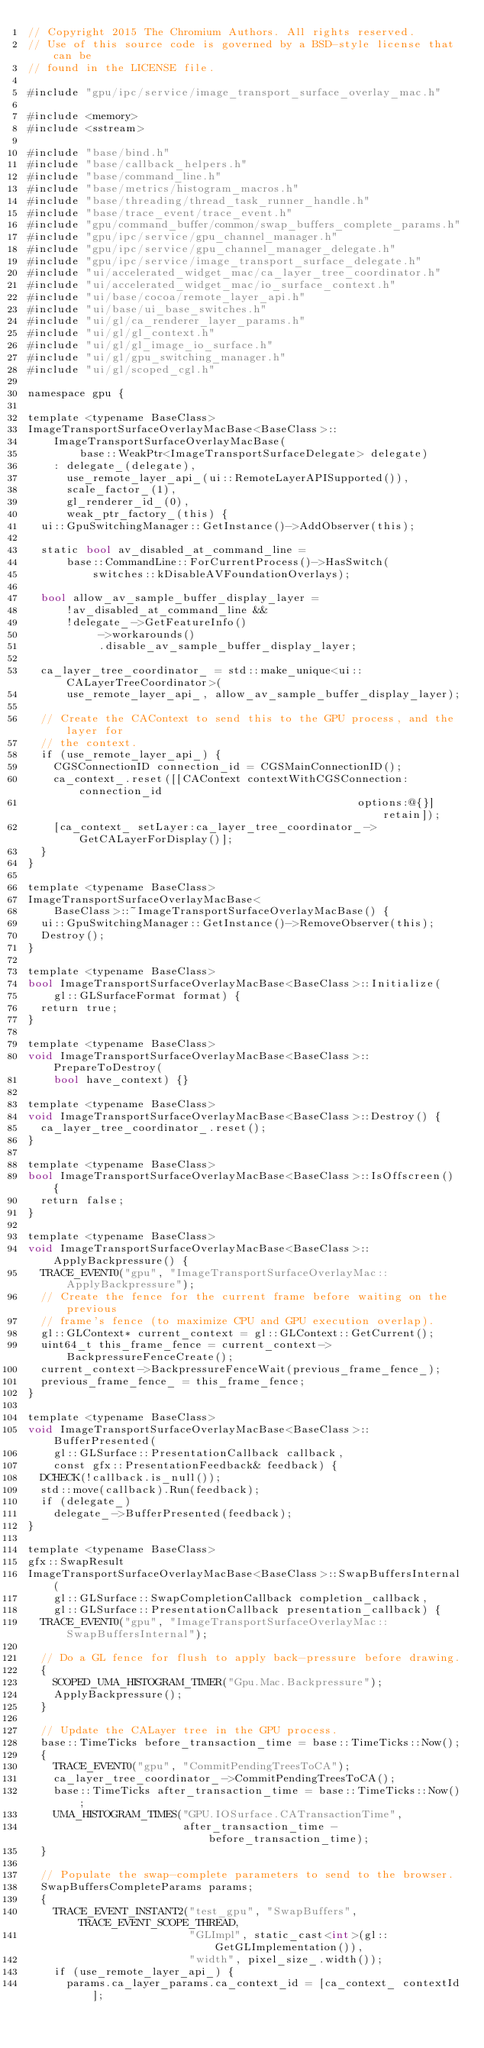<code> <loc_0><loc_0><loc_500><loc_500><_ObjectiveC_>// Copyright 2015 The Chromium Authors. All rights reserved.
// Use of this source code is governed by a BSD-style license that can be
// found in the LICENSE file.

#include "gpu/ipc/service/image_transport_surface_overlay_mac.h"

#include <memory>
#include <sstream>

#include "base/bind.h"
#include "base/callback_helpers.h"
#include "base/command_line.h"
#include "base/metrics/histogram_macros.h"
#include "base/threading/thread_task_runner_handle.h"
#include "base/trace_event/trace_event.h"
#include "gpu/command_buffer/common/swap_buffers_complete_params.h"
#include "gpu/ipc/service/gpu_channel_manager.h"
#include "gpu/ipc/service/gpu_channel_manager_delegate.h"
#include "gpu/ipc/service/image_transport_surface_delegate.h"
#include "ui/accelerated_widget_mac/ca_layer_tree_coordinator.h"
#include "ui/accelerated_widget_mac/io_surface_context.h"
#include "ui/base/cocoa/remote_layer_api.h"
#include "ui/base/ui_base_switches.h"
#include "ui/gl/ca_renderer_layer_params.h"
#include "ui/gl/gl_context.h"
#include "ui/gl/gl_image_io_surface.h"
#include "ui/gl/gpu_switching_manager.h"
#include "ui/gl/scoped_cgl.h"

namespace gpu {

template <typename BaseClass>
ImageTransportSurfaceOverlayMacBase<BaseClass>::
    ImageTransportSurfaceOverlayMacBase(
        base::WeakPtr<ImageTransportSurfaceDelegate> delegate)
    : delegate_(delegate),
      use_remote_layer_api_(ui::RemoteLayerAPISupported()),
      scale_factor_(1),
      gl_renderer_id_(0),
      weak_ptr_factory_(this) {
  ui::GpuSwitchingManager::GetInstance()->AddObserver(this);

  static bool av_disabled_at_command_line =
      base::CommandLine::ForCurrentProcess()->HasSwitch(
          switches::kDisableAVFoundationOverlays);

  bool allow_av_sample_buffer_display_layer =
      !av_disabled_at_command_line &&
      !delegate_->GetFeatureInfo()
           ->workarounds()
           .disable_av_sample_buffer_display_layer;

  ca_layer_tree_coordinator_ = std::make_unique<ui::CALayerTreeCoordinator>(
      use_remote_layer_api_, allow_av_sample_buffer_display_layer);

  // Create the CAContext to send this to the GPU process, and the layer for
  // the context.
  if (use_remote_layer_api_) {
    CGSConnectionID connection_id = CGSMainConnectionID();
    ca_context_.reset([[CAContext contextWithCGSConnection:connection_id
                                                   options:@{}] retain]);
    [ca_context_ setLayer:ca_layer_tree_coordinator_->GetCALayerForDisplay()];
  }
}

template <typename BaseClass>
ImageTransportSurfaceOverlayMacBase<
    BaseClass>::~ImageTransportSurfaceOverlayMacBase() {
  ui::GpuSwitchingManager::GetInstance()->RemoveObserver(this);
  Destroy();
}

template <typename BaseClass>
bool ImageTransportSurfaceOverlayMacBase<BaseClass>::Initialize(
    gl::GLSurfaceFormat format) {
  return true;
}

template <typename BaseClass>
void ImageTransportSurfaceOverlayMacBase<BaseClass>::PrepareToDestroy(
    bool have_context) {}

template <typename BaseClass>
void ImageTransportSurfaceOverlayMacBase<BaseClass>::Destroy() {
  ca_layer_tree_coordinator_.reset();
}

template <typename BaseClass>
bool ImageTransportSurfaceOverlayMacBase<BaseClass>::IsOffscreen() {
  return false;
}

template <typename BaseClass>
void ImageTransportSurfaceOverlayMacBase<BaseClass>::ApplyBackpressure() {
  TRACE_EVENT0("gpu", "ImageTransportSurfaceOverlayMac::ApplyBackpressure");
  // Create the fence for the current frame before waiting on the previous
  // frame's fence (to maximize CPU and GPU execution overlap).
  gl::GLContext* current_context = gl::GLContext::GetCurrent();
  uint64_t this_frame_fence = current_context->BackpressureFenceCreate();
  current_context->BackpressureFenceWait(previous_frame_fence_);
  previous_frame_fence_ = this_frame_fence;
}

template <typename BaseClass>
void ImageTransportSurfaceOverlayMacBase<BaseClass>::BufferPresented(
    gl::GLSurface::PresentationCallback callback,
    const gfx::PresentationFeedback& feedback) {
  DCHECK(!callback.is_null());
  std::move(callback).Run(feedback);
  if (delegate_)
    delegate_->BufferPresented(feedback);
}

template <typename BaseClass>
gfx::SwapResult
ImageTransportSurfaceOverlayMacBase<BaseClass>::SwapBuffersInternal(
    gl::GLSurface::SwapCompletionCallback completion_callback,
    gl::GLSurface::PresentationCallback presentation_callback) {
  TRACE_EVENT0("gpu", "ImageTransportSurfaceOverlayMac::SwapBuffersInternal");

  // Do a GL fence for flush to apply back-pressure before drawing.
  {
    SCOPED_UMA_HISTOGRAM_TIMER("Gpu.Mac.Backpressure");
    ApplyBackpressure();
  }

  // Update the CALayer tree in the GPU process.
  base::TimeTicks before_transaction_time = base::TimeTicks::Now();
  {
    TRACE_EVENT0("gpu", "CommitPendingTreesToCA");
    ca_layer_tree_coordinator_->CommitPendingTreesToCA();
    base::TimeTicks after_transaction_time = base::TimeTicks::Now();
    UMA_HISTOGRAM_TIMES("GPU.IOSurface.CATransactionTime",
                        after_transaction_time - before_transaction_time);
  }

  // Populate the swap-complete parameters to send to the browser.
  SwapBuffersCompleteParams params;
  {
    TRACE_EVENT_INSTANT2("test_gpu", "SwapBuffers", TRACE_EVENT_SCOPE_THREAD,
                         "GLImpl", static_cast<int>(gl::GetGLImplementation()),
                         "width", pixel_size_.width());
    if (use_remote_layer_api_) {
      params.ca_layer_params.ca_context_id = [ca_context_ contextId];</code> 